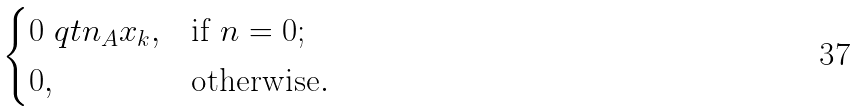Convert formula to latex. <formula><loc_0><loc_0><loc_500><loc_500>\begin{cases} 0 \ q t n _ { A } x _ { k } , & \text {if $n=0$} ; \\ 0 , & \text {otherwise} . \end{cases}</formula> 